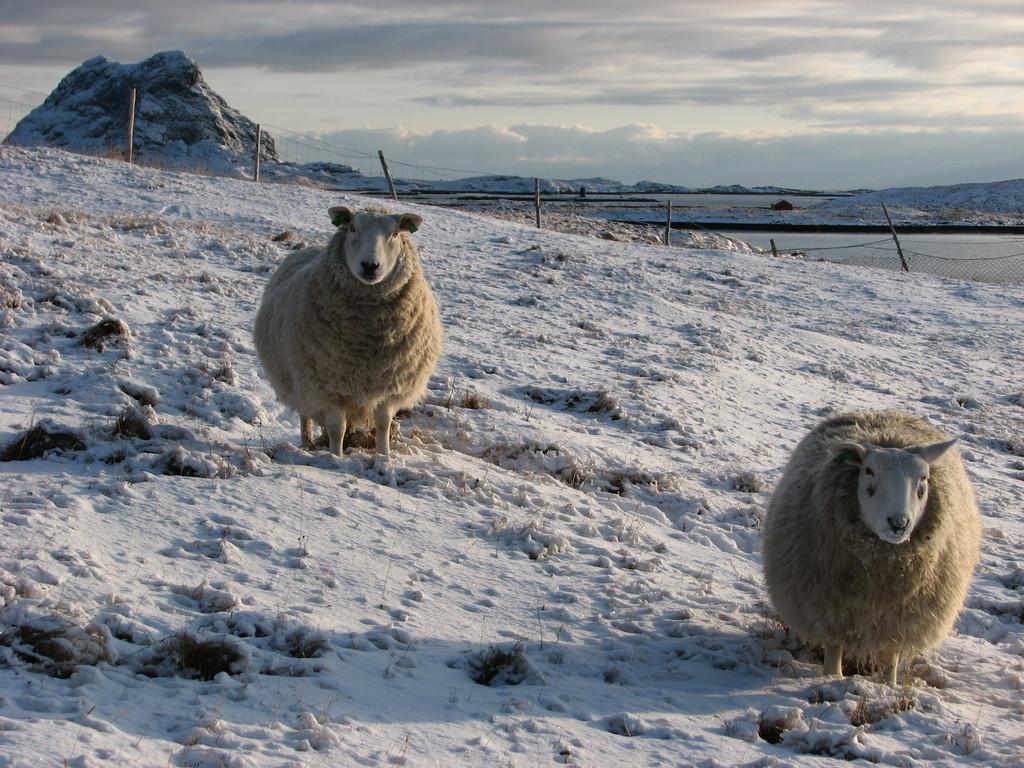Please provide a concise description of this image. In this picture we can see couple of sheep on the ice, in the background we can see net, few poles and hills. 